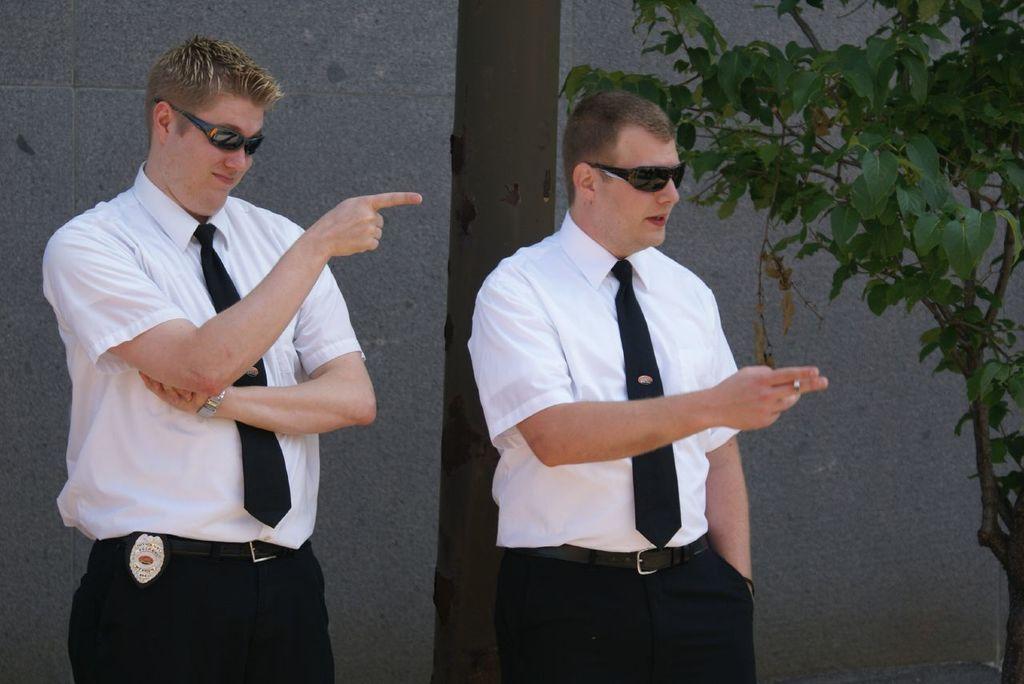How would you summarize this image in a sentence or two? As we can see in the image there is a wall, tree and two people wearing white color shirts. 